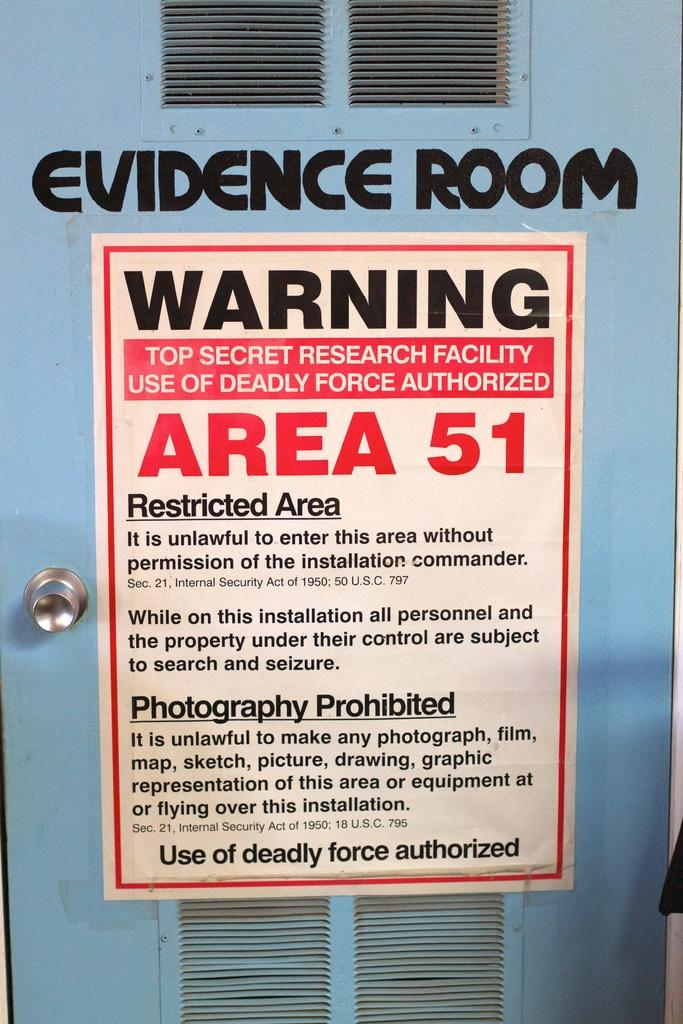<image>
Offer a succinct explanation of the picture presented. A warning sign posted on the door of an evidence room at Area 51. 